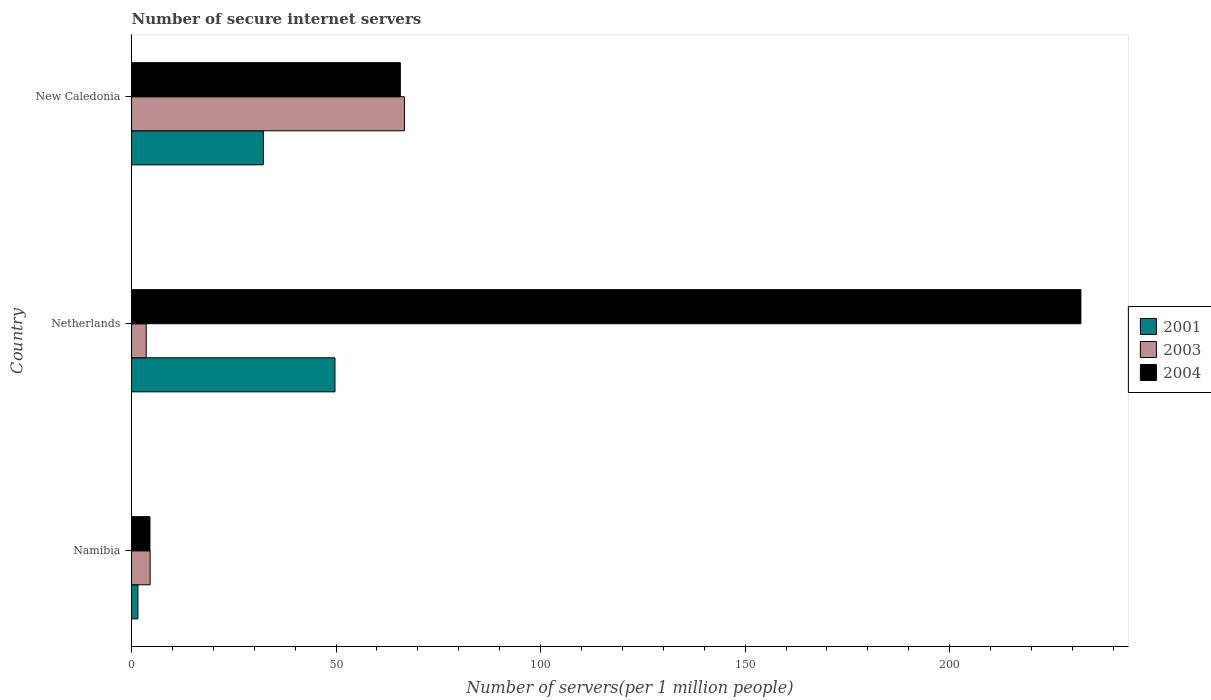How many different coloured bars are there?
Offer a very short reply. 3. How many bars are there on the 1st tick from the bottom?
Give a very brief answer. 3. What is the label of the 3rd group of bars from the top?
Your answer should be compact. Namibia. In how many cases, is the number of bars for a given country not equal to the number of legend labels?
Provide a short and direct response. 0. What is the number of secure internet servers in 2001 in Namibia?
Your answer should be very brief. 1.55. Across all countries, what is the maximum number of secure internet servers in 2001?
Provide a succinct answer. 49.73. Across all countries, what is the minimum number of secure internet servers in 2004?
Provide a short and direct response. 4.49. What is the total number of secure internet servers in 2001 in the graph?
Your response must be concise. 83.5. What is the difference between the number of secure internet servers in 2001 in Netherlands and that in New Caledonia?
Offer a terse response. 17.52. What is the difference between the number of secure internet servers in 2003 in Namibia and the number of secure internet servers in 2004 in Netherlands?
Offer a terse response. -227.56. What is the average number of secure internet servers in 2001 per country?
Keep it short and to the point. 27.83. What is the difference between the number of secure internet servers in 2003 and number of secure internet servers in 2004 in Namibia?
Ensure brevity in your answer.  0.05. In how many countries, is the number of secure internet servers in 2001 greater than 160 ?
Keep it short and to the point. 0. What is the ratio of the number of secure internet servers in 2001 in Namibia to that in Netherlands?
Give a very brief answer. 0.03. Is the difference between the number of secure internet servers in 2003 in Netherlands and New Caledonia greater than the difference between the number of secure internet servers in 2004 in Netherlands and New Caledonia?
Give a very brief answer. No. What is the difference between the highest and the second highest number of secure internet servers in 2003?
Provide a succinct answer. 62.16. What is the difference between the highest and the lowest number of secure internet servers in 2004?
Provide a short and direct response. 227.61. What does the 1st bar from the bottom in Namibia represents?
Offer a very short reply. 2001. How many countries are there in the graph?
Ensure brevity in your answer.  3. What is the difference between two consecutive major ticks on the X-axis?
Ensure brevity in your answer.  50. Does the graph contain grids?
Offer a terse response. No. Where does the legend appear in the graph?
Make the answer very short. Center right. How many legend labels are there?
Provide a succinct answer. 3. What is the title of the graph?
Your answer should be compact. Number of secure internet servers. Does "1969" appear as one of the legend labels in the graph?
Give a very brief answer. No. What is the label or title of the X-axis?
Keep it short and to the point. Number of servers(per 1 million people). What is the label or title of the Y-axis?
Your answer should be compact. Country. What is the Number of servers(per 1 million people) in 2001 in Namibia?
Your answer should be very brief. 1.55. What is the Number of servers(per 1 million people) of 2003 in Namibia?
Provide a succinct answer. 4.54. What is the Number of servers(per 1 million people) in 2004 in Namibia?
Make the answer very short. 4.49. What is the Number of servers(per 1 million people) in 2001 in Netherlands?
Ensure brevity in your answer.  49.73. What is the Number of servers(per 1 million people) of 2003 in Netherlands?
Your answer should be compact. 3.57. What is the Number of servers(per 1 million people) of 2004 in Netherlands?
Your response must be concise. 232.1. What is the Number of servers(per 1 million people) in 2001 in New Caledonia?
Offer a very short reply. 32.21. What is the Number of servers(per 1 million people) of 2003 in New Caledonia?
Ensure brevity in your answer.  66.71. What is the Number of servers(per 1 million people) of 2004 in New Caledonia?
Provide a succinct answer. 65.7. Across all countries, what is the maximum Number of servers(per 1 million people) of 2001?
Provide a short and direct response. 49.73. Across all countries, what is the maximum Number of servers(per 1 million people) of 2003?
Offer a terse response. 66.71. Across all countries, what is the maximum Number of servers(per 1 million people) in 2004?
Give a very brief answer. 232.1. Across all countries, what is the minimum Number of servers(per 1 million people) in 2001?
Your response must be concise. 1.55. Across all countries, what is the minimum Number of servers(per 1 million people) in 2003?
Give a very brief answer. 3.57. Across all countries, what is the minimum Number of servers(per 1 million people) of 2004?
Give a very brief answer. 4.49. What is the total Number of servers(per 1 million people) of 2001 in the graph?
Your answer should be very brief. 83.5. What is the total Number of servers(per 1 million people) of 2003 in the graph?
Keep it short and to the point. 74.82. What is the total Number of servers(per 1 million people) of 2004 in the graph?
Your answer should be very brief. 302.3. What is the difference between the Number of servers(per 1 million people) of 2001 in Namibia and that in Netherlands?
Your answer should be very brief. -48.18. What is the difference between the Number of servers(per 1 million people) in 2003 in Namibia and that in Netherlands?
Your response must be concise. 0.97. What is the difference between the Number of servers(per 1 million people) in 2004 in Namibia and that in Netherlands?
Give a very brief answer. -227.61. What is the difference between the Number of servers(per 1 million people) of 2001 in Namibia and that in New Caledonia?
Your answer should be very brief. -30.66. What is the difference between the Number of servers(per 1 million people) in 2003 in Namibia and that in New Caledonia?
Ensure brevity in your answer.  -62.16. What is the difference between the Number of servers(per 1 million people) in 2004 in Namibia and that in New Caledonia?
Keep it short and to the point. -61.21. What is the difference between the Number of servers(per 1 million people) in 2001 in Netherlands and that in New Caledonia?
Provide a short and direct response. 17.52. What is the difference between the Number of servers(per 1 million people) of 2003 in Netherlands and that in New Caledonia?
Make the answer very short. -63.13. What is the difference between the Number of servers(per 1 million people) of 2004 in Netherlands and that in New Caledonia?
Provide a short and direct response. 166.4. What is the difference between the Number of servers(per 1 million people) in 2001 in Namibia and the Number of servers(per 1 million people) in 2003 in Netherlands?
Provide a succinct answer. -2.02. What is the difference between the Number of servers(per 1 million people) of 2001 in Namibia and the Number of servers(per 1 million people) of 2004 in Netherlands?
Give a very brief answer. -230.55. What is the difference between the Number of servers(per 1 million people) of 2003 in Namibia and the Number of servers(per 1 million people) of 2004 in Netherlands?
Keep it short and to the point. -227.56. What is the difference between the Number of servers(per 1 million people) in 2001 in Namibia and the Number of servers(per 1 million people) in 2003 in New Caledonia?
Your answer should be very brief. -65.15. What is the difference between the Number of servers(per 1 million people) of 2001 in Namibia and the Number of servers(per 1 million people) of 2004 in New Caledonia?
Your response must be concise. -64.15. What is the difference between the Number of servers(per 1 million people) of 2003 in Namibia and the Number of servers(per 1 million people) of 2004 in New Caledonia?
Your answer should be very brief. -61.16. What is the difference between the Number of servers(per 1 million people) of 2001 in Netherlands and the Number of servers(per 1 million people) of 2003 in New Caledonia?
Offer a terse response. -16.97. What is the difference between the Number of servers(per 1 million people) of 2001 in Netherlands and the Number of servers(per 1 million people) of 2004 in New Caledonia?
Give a very brief answer. -15.97. What is the difference between the Number of servers(per 1 million people) in 2003 in Netherlands and the Number of servers(per 1 million people) in 2004 in New Caledonia?
Offer a terse response. -62.13. What is the average Number of servers(per 1 million people) in 2001 per country?
Your answer should be very brief. 27.83. What is the average Number of servers(per 1 million people) in 2003 per country?
Ensure brevity in your answer.  24.94. What is the average Number of servers(per 1 million people) in 2004 per country?
Your response must be concise. 100.77. What is the difference between the Number of servers(per 1 million people) in 2001 and Number of servers(per 1 million people) in 2003 in Namibia?
Your response must be concise. -2.99. What is the difference between the Number of servers(per 1 million people) in 2001 and Number of servers(per 1 million people) in 2004 in Namibia?
Keep it short and to the point. -2.94. What is the difference between the Number of servers(per 1 million people) of 2003 and Number of servers(per 1 million people) of 2004 in Namibia?
Ensure brevity in your answer.  0.05. What is the difference between the Number of servers(per 1 million people) in 2001 and Number of servers(per 1 million people) in 2003 in Netherlands?
Offer a very short reply. 46.16. What is the difference between the Number of servers(per 1 million people) of 2001 and Number of servers(per 1 million people) of 2004 in Netherlands?
Provide a succinct answer. -182.37. What is the difference between the Number of servers(per 1 million people) in 2003 and Number of servers(per 1 million people) in 2004 in Netherlands?
Ensure brevity in your answer.  -228.53. What is the difference between the Number of servers(per 1 million people) in 2001 and Number of servers(per 1 million people) in 2003 in New Caledonia?
Your answer should be very brief. -34.5. What is the difference between the Number of servers(per 1 million people) of 2001 and Number of servers(per 1 million people) of 2004 in New Caledonia?
Offer a terse response. -33.49. What is the ratio of the Number of servers(per 1 million people) of 2001 in Namibia to that in Netherlands?
Make the answer very short. 0.03. What is the ratio of the Number of servers(per 1 million people) in 2003 in Namibia to that in Netherlands?
Give a very brief answer. 1.27. What is the ratio of the Number of servers(per 1 million people) of 2004 in Namibia to that in Netherlands?
Your answer should be compact. 0.02. What is the ratio of the Number of servers(per 1 million people) in 2001 in Namibia to that in New Caledonia?
Provide a succinct answer. 0.05. What is the ratio of the Number of servers(per 1 million people) of 2003 in Namibia to that in New Caledonia?
Provide a succinct answer. 0.07. What is the ratio of the Number of servers(per 1 million people) in 2004 in Namibia to that in New Caledonia?
Keep it short and to the point. 0.07. What is the ratio of the Number of servers(per 1 million people) in 2001 in Netherlands to that in New Caledonia?
Your answer should be compact. 1.54. What is the ratio of the Number of servers(per 1 million people) in 2003 in Netherlands to that in New Caledonia?
Make the answer very short. 0.05. What is the ratio of the Number of servers(per 1 million people) of 2004 in Netherlands to that in New Caledonia?
Provide a short and direct response. 3.53. What is the difference between the highest and the second highest Number of servers(per 1 million people) in 2001?
Provide a succinct answer. 17.52. What is the difference between the highest and the second highest Number of servers(per 1 million people) in 2003?
Your response must be concise. 62.16. What is the difference between the highest and the second highest Number of servers(per 1 million people) of 2004?
Your response must be concise. 166.4. What is the difference between the highest and the lowest Number of servers(per 1 million people) of 2001?
Your response must be concise. 48.18. What is the difference between the highest and the lowest Number of servers(per 1 million people) in 2003?
Make the answer very short. 63.13. What is the difference between the highest and the lowest Number of servers(per 1 million people) of 2004?
Keep it short and to the point. 227.61. 